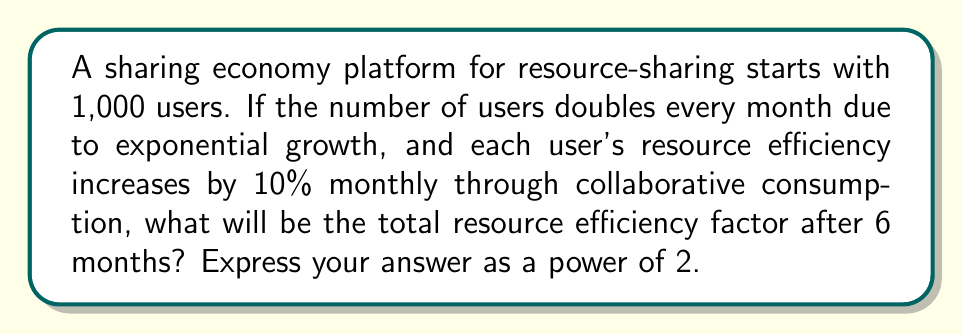Help me with this question. Let's break this problem down step-by-step:

1) First, let's calculate the number of users after 6 months:
   Initial users: 1,000
   Growth rate: doubles every month
   Number of months: 6
   
   Final number of users = $1000 \cdot 2^6 = 64,000$

2) Now, let's calculate the resource efficiency factor:
   Monthly increase: 10% = 1.1
   Number of months: 6
   
   Efficiency factor = $1.1^6 \approx 1.7716$

3) The total resource efficiency factor is the product of the increase in users and the increase in efficiency per user:

   Total factor = $64 \cdot 1.7716 = 113.3824$

4) We need to express this as a power of 2. Let's use logarithms:

   $\log_2(113.3824) = 6.8261$

5) Therefore, the total resource efficiency factor can be expressed as:

   $2^{6.8261}$

We can round this to 4 decimal places for our final answer.
Answer: $2^{6.8261}$ 